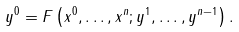Convert formula to latex. <formula><loc_0><loc_0><loc_500><loc_500>y ^ { 0 } = F \left ( x ^ { 0 } , \dots , x ^ { n } ; y ^ { 1 } , \dots , y ^ { n - 1 } \right ) .</formula> 